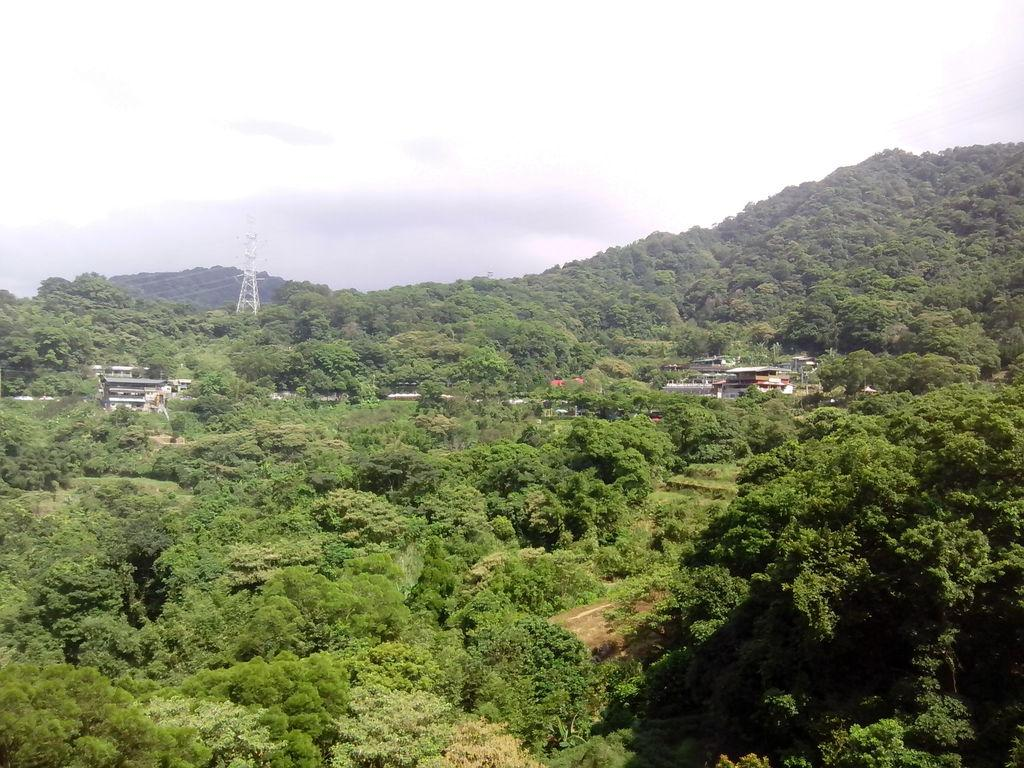What is the possible location from where the image was taken? The image might be taken from outside of the city. What type of vegetation can be seen in the image? There are trees in the image. What type of structures are visible in the image? There are houses, buildings, and towers in the image. What else can be seen in the image besides structures? There are electric wires in the image. What is visible at the top of the image? The sky is visible at the top of the image. What type of punishment is being carried out in the image? There is no indication of punishment in the image; it features trees, houses, buildings, towers, electric wires, and the sky. How many centimeters long is the jail in the image? There is no jail present in the image, so it is not possible to determine its length. 